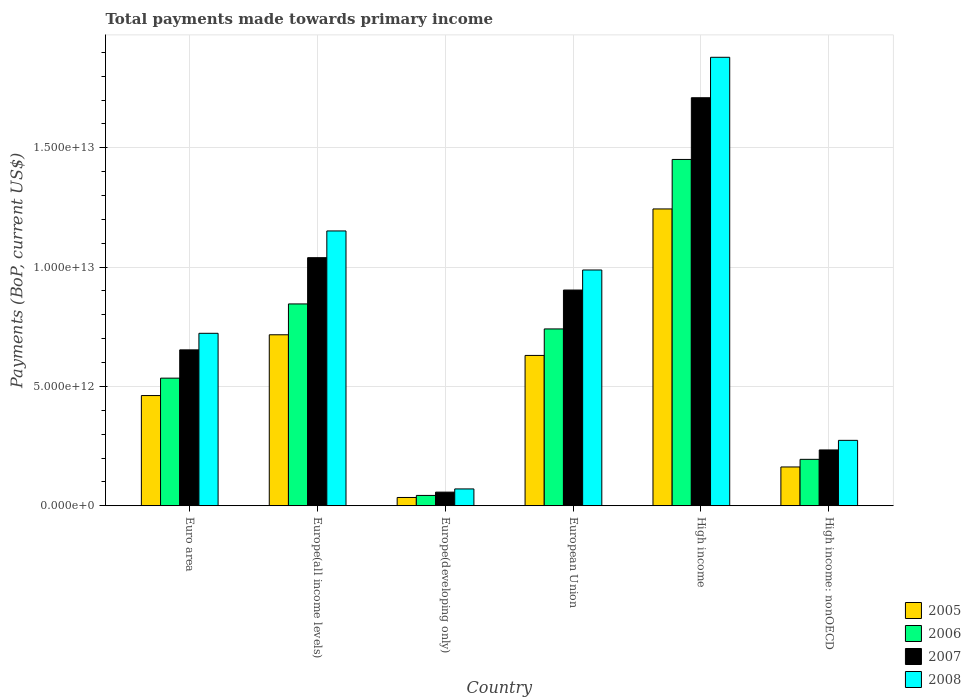How many groups of bars are there?
Give a very brief answer. 6. Are the number of bars per tick equal to the number of legend labels?
Ensure brevity in your answer.  Yes. Are the number of bars on each tick of the X-axis equal?
Offer a very short reply. Yes. How many bars are there on the 5th tick from the left?
Give a very brief answer. 4. How many bars are there on the 4th tick from the right?
Offer a very short reply. 4. What is the label of the 2nd group of bars from the left?
Your response must be concise. Europe(all income levels). What is the total payments made towards primary income in 2005 in Europe(developing only)?
Ensure brevity in your answer.  3.46e+11. Across all countries, what is the maximum total payments made towards primary income in 2008?
Your response must be concise. 1.88e+13. Across all countries, what is the minimum total payments made towards primary income in 2007?
Ensure brevity in your answer.  5.70e+11. In which country was the total payments made towards primary income in 2005 maximum?
Offer a very short reply. High income. In which country was the total payments made towards primary income in 2006 minimum?
Your answer should be very brief. Europe(developing only). What is the total total payments made towards primary income in 2006 in the graph?
Provide a short and direct response. 3.81e+13. What is the difference between the total payments made towards primary income in 2008 in Europe(developing only) and that in High income?
Your response must be concise. -1.81e+13. What is the difference between the total payments made towards primary income in 2007 in European Union and the total payments made towards primary income in 2006 in High income?
Offer a very short reply. -5.47e+12. What is the average total payments made towards primary income in 2008 per country?
Give a very brief answer. 8.48e+12. What is the difference between the total payments made towards primary income of/in 2005 and total payments made towards primary income of/in 2006 in High income: nonOECD?
Make the answer very short. -3.20e+11. In how many countries, is the total payments made towards primary income in 2005 greater than 8000000000000 US$?
Provide a succinct answer. 1. What is the ratio of the total payments made towards primary income in 2008 in Europe(developing only) to that in European Union?
Give a very brief answer. 0.07. Is the total payments made towards primary income in 2006 in Europe(all income levels) less than that in High income: nonOECD?
Your answer should be compact. No. Is the difference between the total payments made towards primary income in 2005 in Euro area and Europe(developing only) greater than the difference between the total payments made towards primary income in 2006 in Euro area and Europe(developing only)?
Offer a terse response. No. What is the difference between the highest and the second highest total payments made towards primary income in 2006?
Offer a terse response. 1.05e+12. What is the difference between the highest and the lowest total payments made towards primary income in 2005?
Offer a terse response. 1.21e+13. In how many countries, is the total payments made towards primary income in 2007 greater than the average total payments made towards primary income in 2007 taken over all countries?
Provide a succinct answer. 3. What does the 1st bar from the right in High income: nonOECD represents?
Provide a succinct answer. 2008. Is it the case that in every country, the sum of the total payments made towards primary income in 2008 and total payments made towards primary income in 2005 is greater than the total payments made towards primary income in 2006?
Your answer should be compact. Yes. How many bars are there?
Keep it short and to the point. 24. Are all the bars in the graph horizontal?
Give a very brief answer. No. How many countries are there in the graph?
Your response must be concise. 6. What is the difference between two consecutive major ticks on the Y-axis?
Give a very brief answer. 5.00e+12. Are the values on the major ticks of Y-axis written in scientific E-notation?
Make the answer very short. Yes. Does the graph contain any zero values?
Your response must be concise. No. Where does the legend appear in the graph?
Your answer should be compact. Bottom right. What is the title of the graph?
Your response must be concise. Total payments made towards primary income. What is the label or title of the X-axis?
Keep it short and to the point. Country. What is the label or title of the Y-axis?
Keep it short and to the point. Payments (BoP, current US$). What is the Payments (BoP, current US$) of 2005 in Euro area?
Your answer should be very brief. 4.62e+12. What is the Payments (BoP, current US$) in 2006 in Euro area?
Offer a very short reply. 5.35e+12. What is the Payments (BoP, current US$) of 2007 in Euro area?
Provide a short and direct response. 6.53e+12. What is the Payments (BoP, current US$) in 2008 in Euro area?
Offer a very short reply. 7.23e+12. What is the Payments (BoP, current US$) of 2005 in Europe(all income levels)?
Offer a terse response. 7.16e+12. What is the Payments (BoP, current US$) of 2006 in Europe(all income levels)?
Offer a terse response. 8.46e+12. What is the Payments (BoP, current US$) of 2007 in Europe(all income levels)?
Offer a terse response. 1.04e+13. What is the Payments (BoP, current US$) in 2008 in Europe(all income levels)?
Provide a short and direct response. 1.15e+13. What is the Payments (BoP, current US$) in 2005 in Europe(developing only)?
Keep it short and to the point. 3.46e+11. What is the Payments (BoP, current US$) of 2006 in Europe(developing only)?
Offer a terse response. 4.32e+11. What is the Payments (BoP, current US$) of 2007 in Europe(developing only)?
Provide a short and direct response. 5.70e+11. What is the Payments (BoP, current US$) of 2008 in Europe(developing only)?
Offer a very short reply. 7.04e+11. What is the Payments (BoP, current US$) of 2005 in European Union?
Your response must be concise. 6.30e+12. What is the Payments (BoP, current US$) of 2006 in European Union?
Your response must be concise. 7.41e+12. What is the Payments (BoP, current US$) of 2007 in European Union?
Give a very brief answer. 9.04e+12. What is the Payments (BoP, current US$) of 2008 in European Union?
Provide a succinct answer. 9.88e+12. What is the Payments (BoP, current US$) of 2005 in High income?
Provide a short and direct response. 1.24e+13. What is the Payments (BoP, current US$) of 2006 in High income?
Your response must be concise. 1.45e+13. What is the Payments (BoP, current US$) in 2007 in High income?
Your answer should be compact. 1.71e+13. What is the Payments (BoP, current US$) of 2008 in High income?
Your response must be concise. 1.88e+13. What is the Payments (BoP, current US$) of 2005 in High income: nonOECD?
Make the answer very short. 1.62e+12. What is the Payments (BoP, current US$) in 2006 in High income: nonOECD?
Keep it short and to the point. 1.94e+12. What is the Payments (BoP, current US$) in 2007 in High income: nonOECD?
Offer a terse response. 2.34e+12. What is the Payments (BoP, current US$) in 2008 in High income: nonOECD?
Give a very brief answer. 2.74e+12. Across all countries, what is the maximum Payments (BoP, current US$) of 2005?
Provide a short and direct response. 1.24e+13. Across all countries, what is the maximum Payments (BoP, current US$) in 2006?
Make the answer very short. 1.45e+13. Across all countries, what is the maximum Payments (BoP, current US$) in 2007?
Offer a very short reply. 1.71e+13. Across all countries, what is the maximum Payments (BoP, current US$) in 2008?
Provide a succinct answer. 1.88e+13. Across all countries, what is the minimum Payments (BoP, current US$) in 2005?
Offer a terse response. 3.46e+11. Across all countries, what is the minimum Payments (BoP, current US$) of 2006?
Your answer should be compact. 4.32e+11. Across all countries, what is the minimum Payments (BoP, current US$) in 2007?
Make the answer very short. 5.70e+11. Across all countries, what is the minimum Payments (BoP, current US$) of 2008?
Your response must be concise. 7.04e+11. What is the total Payments (BoP, current US$) in 2005 in the graph?
Offer a very short reply. 3.25e+13. What is the total Payments (BoP, current US$) of 2006 in the graph?
Give a very brief answer. 3.81e+13. What is the total Payments (BoP, current US$) of 2007 in the graph?
Provide a succinct answer. 4.60e+13. What is the total Payments (BoP, current US$) in 2008 in the graph?
Your answer should be very brief. 5.09e+13. What is the difference between the Payments (BoP, current US$) of 2005 in Euro area and that in Europe(all income levels)?
Keep it short and to the point. -2.55e+12. What is the difference between the Payments (BoP, current US$) of 2006 in Euro area and that in Europe(all income levels)?
Offer a very short reply. -3.11e+12. What is the difference between the Payments (BoP, current US$) of 2007 in Euro area and that in Europe(all income levels)?
Your answer should be compact. -3.86e+12. What is the difference between the Payments (BoP, current US$) in 2008 in Euro area and that in Europe(all income levels)?
Provide a short and direct response. -4.29e+12. What is the difference between the Payments (BoP, current US$) of 2005 in Euro area and that in Europe(developing only)?
Give a very brief answer. 4.27e+12. What is the difference between the Payments (BoP, current US$) of 2006 in Euro area and that in Europe(developing only)?
Provide a succinct answer. 4.92e+12. What is the difference between the Payments (BoP, current US$) of 2007 in Euro area and that in Europe(developing only)?
Ensure brevity in your answer.  5.96e+12. What is the difference between the Payments (BoP, current US$) of 2008 in Euro area and that in Europe(developing only)?
Keep it short and to the point. 6.52e+12. What is the difference between the Payments (BoP, current US$) of 2005 in Euro area and that in European Union?
Provide a short and direct response. -1.68e+12. What is the difference between the Payments (BoP, current US$) in 2006 in Euro area and that in European Union?
Ensure brevity in your answer.  -2.06e+12. What is the difference between the Payments (BoP, current US$) in 2007 in Euro area and that in European Union?
Offer a very short reply. -2.51e+12. What is the difference between the Payments (BoP, current US$) of 2008 in Euro area and that in European Union?
Make the answer very short. -2.65e+12. What is the difference between the Payments (BoP, current US$) in 2005 in Euro area and that in High income?
Make the answer very short. -7.82e+12. What is the difference between the Payments (BoP, current US$) in 2006 in Euro area and that in High income?
Provide a succinct answer. -9.17e+12. What is the difference between the Payments (BoP, current US$) of 2007 in Euro area and that in High income?
Provide a succinct answer. -1.06e+13. What is the difference between the Payments (BoP, current US$) of 2008 in Euro area and that in High income?
Ensure brevity in your answer.  -1.16e+13. What is the difference between the Payments (BoP, current US$) of 2005 in Euro area and that in High income: nonOECD?
Ensure brevity in your answer.  2.99e+12. What is the difference between the Payments (BoP, current US$) of 2006 in Euro area and that in High income: nonOECD?
Provide a short and direct response. 3.40e+12. What is the difference between the Payments (BoP, current US$) in 2007 in Euro area and that in High income: nonOECD?
Offer a terse response. 4.19e+12. What is the difference between the Payments (BoP, current US$) in 2008 in Euro area and that in High income: nonOECD?
Ensure brevity in your answer.  4.49e+12. What is the difference between the Payments (BoP, current US$) of 2005 in Europe(all income levels) and that in Europe(developing only)?
Your answer should be very brief. 6.82e+12. What is the difference between the Payments (BoP, current US$) of 2006 in Europe(all income levels) and that in Europe(developing only)?
Keep it short and to the point. 8.03e+12. What is the difference between the Payments (BoP, current US$) of 2007 in Europe(all income levels) and that in Europe(developing only)?
Your response must be concise. 9.83e+12. What is the difference between the Payments (BoP, current US$) of 2008 in Europe(all income levels) and that in Europe(developing only)?
Make the answer very short. 1.08e+13. What is the difference between the Payments (BoP, current US$) of 2005 in Europe(all income levels) and that in European Union?
Keep it short and to the point. 8.66e+11. What is the difference between the Payments (BoP, current US$) in 2006 in Europe(all income levels) and that in European Union?
Ensure brevity in your answer.  1.05e+12. What is the difference between the Payments (BoP, current US$) of 2007 in Europe(all income levels) and that in European Union?
Your answer should be very brief. 1.36e+12. What is the difference between the Payments (BoP, current US$) of 2008 in Europe(all income levels) and that in European Union?
Your answer should be very brief. 1.64e+12. What is the difference between the Payments (BoP, current US$) in 2005 in Europe(all income levels) and that in High income?
Offer a terse response. -5.27e+12. What is the difference between the Payments (BoP, current US$) in 2006 in Europe(all income levels) and that in High income?
Ensure brevity in your answer.  -6.06e+12. What is the difference between the Payments (BoP, current US$) in 2007 in Europe(all income levels) and that in High income?
Make the answer very short. -6.70e+12. What is the difference between the Payments (BoP, current US$) of 2008 in Europe(all income levels) and that in High income?
Provide a short and direct response. -7.28e+12. What is the difference between the Payments (BoP, current US$) in 2005 in Europe(all income levels) and that in High income: nonOECD?
Your response must be concise. 5.54e+12. What is the difference between the Payments (BoP, current US$) in 2006 in Europe(all income levels) and that in High income: nonOECD?
Your answer should be compact. 6.51e+12. What is the difference between the Payments (BoP, current US$) in 2007 in Europe(all income levels) and that in High income: nonOECD?
Give a very brief answer. 8.06e+12. What is the difference between the Payments (BoP, current US$) of 2008 in Europe(all income levels) and that in High income: nonOECD?
Your answer should be compact. 8.78e+12. What is the difference between the Payments (BoP, current US$) of 2005 in Europe(developing only) and that in European Union?
Offer a very short reply. -5.95e+12. What is the difference between the Payments (BoP, current US$) of 2006 in Europe(developing only) and that in European Union?
Offer a terse response. -6.98e+12. What is the difference between the Payments (BoP, current US$) in 2007 in Europe(developing only) and that in European Union?
Provide a short and direct response. -8.47e+12. What is the difference between the Payments (BoP, current US$) in 2008 in Europe(developing only) and that in European Union?
Ensure brevity in your answer.  -9.18e+12. What is the difference between the Payments (BoP, current US$) of 2005 in Europe(developing only) and that in High income?
Make the answer very short. -1.21e+13. What is the difference between the Payments (BoP, current US$) in 2006 in Europe(developing only) and that in High income?
Your answer should be very brief. -1.41e+13. What is the difference between the Payments (BoP, current US$) in 2007 in Europe(developing only) and that in High income?
Provide a succinct answer. -1.65e+13. What is the difference between the Payments (BoP, current US$) in 2008 in Europe(developing only) and that in High income?
Provide a succinct answer. -1.81e+13. What is the difference between the Payments (BoP, current US$) of 2005 in Europe(developing only) and that in High income: nonOECD?
Make the answer very short. -1.28e+12. What is the difference between the Payments (BoP, current US$) in 2006 in Europe(developing only) and that in High income: nonOECD?
Provide a succinct answer. -1.51e+12. What is the difference between the Payments (BoP, current US$) of 2007 in Europe(developing only) and that in High income: nonOECD?
Give a very brief answer. -1.77e+12. What is the difference between the Payments (BoP, current US$) in 2008 in Europe(developing only) and that in High income: nonOECD?
Make the answer very short. -2.04e+12. What is the difference between the Payments (BoP, current US$) of 2005 in European Union and that in High income?
Provide a short and direct response. -6.14e+12. What is the difference between the Payments (BoP, current US$) of 2006 in European Union and that in High income?
Your answer should be compact. -7.10e+12. What is the difference between the Payments (BoP, current US$) in 2007 in European Union and that in High income?
Offer a terse response. -8.06e+12. What is the difference between the Payments (BoP, current US$) of 2008 in European Union and that in High income?
Your response must be concise. -8.91e+12. What is the difference between the Payments (BoP, current US$) in 2005 in European Union and that in High income: nonOECD?
Provide a short and direct response. 4.67e+12. What is the difference between the Payments (BoP, current US$) of 2006 in European Union and that in High income: nonOECD?
Ensure brevity in your answer.  5.47e+12. What is the difference between the Payments (BoP, current US$) in 2007 in European Union and that in High income: nonOECD?
Ensure brevity in your answer.  6.70e+12. What is the difference between the Payments (BoP, current US$) in 2008 in European Union and that in High income: nonOECD?
Give a very brief answer. 7.14e+12. What is the difference between the Payments (BoP, current US$) in 2005 in High income and that in High income: nonOECD?
Your answer should be compact. 1.08e+13. What is the difference between the Payments (BoP, current US$) of 2006 in High income and that in High income: nonOECD?
Your response must be concise. 1.26e+13. What is the difference between the Payments (BoP, current US$) of 2007 in High income and that in High income: nonOECD?
Offer a very short reply. 1.48e+13. What is the difference between the Payments (BoP, current US$) of 2008 in High income and that in High income: nonOECD?
Your answer should be compact. 1.61e+13. What is the difference between the Payments (BoP, current US$) of 2005 in Euro area and the Payments (BoP, current US$) of 2006 in Europe(all income levels)?
Offer a very short reply. -3.84e+12. What is the difference between the Payments (BoP, current US$) in 2005 in Euro area and the Payments (BoP, current US$) in 2007 in Europe(all income levels)?
Give a very brief answer. -5.78e+12. What is the difference between the Payments (BoP, current US$) in 2005 in Euro area and the Payments (BoP, current US$) in 2008 in Europe(all income levels)?
Your response must be concise. -6.90e+12. What is the difference between the Payments (BoP, current US$) of 2006 in Euro area and the Payments (BoP, current US$) of 2007 in Europe(all income levels)?
Your response must be concise. -5.05e+12. What is the difference between the Payments (BoP, current US$) of 2006 in Euro area and the Payments (BoP, current US$) of 2008 in Europe(all income levels)?
Offer a terse response. -6.17e+12. What is the difference between the Payments (BoP, current US$) in 2007 in Euro area and the Payments (BoP, current US$) in 2008 in Europe(all income levels)?
Your answer should be compact. -4.98e+12. What is the difference between the Payments (BoP, current US$) in 2005 in Euro area and the Payments (BoP, current US$) in 2006 in Europe(developing only)?
Your answer should be very brief. 4.19e+12. What is the difference between the Payments (BoP, current US$) of 2005 in Euro area and the Payments (BoP, current US$) of 2007 in Europe(developing only)?
Give a very brief answer. 4.05e+12. What is the difference between the Payments (BoP, current US$) of 2005 in Euro area and the Payments (BoP, current US$) of 2008 in Europe(developing only)?
Provide a succinct answer. 3.91e+12. What is the difference between the Payments (BoP, current US$) of 2006 in Euro area and the Payments (BoP, current US$) of 2007 in Europe(developing only)?
Offer a very short reply. 4.78e+12. What is the difference between the Payments (BoP, current US$) in 2006 in Euro area and the Payments (BoP, current US$) in 2008 in Europe(developing only)?
Your answer should be compact. 4.64e+12. What is the difference between the Payments (BoP, current US$) in 2007 in Euro area and the Payments (BoP, current US$) in 2008 in Europe(developing only)?
Provide a succinct answer. 5.83e+12. What is the difference between the Payments (BoP, current US$) in 2005 in Euro area and the Payments (BoP, current US$) in 2006 in European Union?
Give a very brief answer. -2.79e+12. What is the difference between the Payments (BoP, current US$) in 2005 in Euro area and the Payments (BoP, current US$) in 2007 in European Union?
Offer a very short reply. -4.42e+12. What is the difference between the Payments (BoP, current US$) of 2005 in Euro area and the Payments (BoP, current US$) of 2008 in European Union?
Provide a succinct answer. -5.26e+12. What is the difference between the Payments (BoP, current US$) of 2006 in Euro area and the Payments (BoP, current US$) of 2007 in European Union?
Ensure brevity in your answer.  -3.69e+12. What is the difference between the Payments (BoP, current US$) of 2006 in Euro area and the Payments (BoP, current US$) of 2008 in European Union?
Make the answer very short. -4.53e+12. What is the difference between the Payments (BoP, current US$) in 2007 in Euro area and the Payments (BoP, current US$) in 2008 in European Union?
Give a very brief answer. -3.35e+12. What is the difference between the Payments (BoP, current US$) of 2005 in Euro area and the Payments (BoP, current US$) of 2006 in High income?
Your answer should be compact. -9.90e+12. What is the difference between the Payments (BoP, current US$) of 2005 in Euro area and the Payments (BoP, current US$) of 2007 in High income?
Give a very brief answer. -1.25e+13. What is the difference between the Payments (BoP, current US$) of 2005 in Euro area and the Payments (BoP, current US$) of 2008 in High income?
Keep it short and to the point. -1.42e+13. What is the difference between the Payments (BoP, current US$) of 2006 in Euro area and the Payments (BoP, current US$) of 2007 in High income?
Keep it short and to the point. -1.18e+13. What is the difference between the Payments (BoP, current US$) of 2006 in Euro area and the Payments (BoP, current US$) of 2008 in High income?
Offer a terse response. -1.34e+13. What is the difference between the Payments (BoP, current US$) of 2007 in Euro area and the Payments (BoP, current US$) of 2008 in High income?
Offer a very short reply. -1.23e+13. What is the difference between the Payments (BoP, current US$) of 2005 in Euro area and the Payments (BoP, current US$) of 2006 in High income: nonOECD?
Keep it short and to the point. 2.67e+12. What is the difference between the Payments (BoP, current US$) of 2005 in Euro area and the Payments (BoP, current US$) of 2007 in High income: nonOECD?
Your response must be concise. 2.28e+12. What is the difference between the Payments (BoP, current US$) of 2005 in Euro area and the Payments (BoP, current US$) of 2008 in High income: nonOECD?
Provide a short and direct response. 1.88e+12. What is the difference between the Payments (BoP, current US$) of 2006 in Euro area and the Payments (BoP, current US$) of 2007 in High income: nonOECD?
Your response must be concise. 3.01e+12. What is the difference between the Payments (BoP, current US$) in 2006 in Euro area and the Payments (BoP, current US$) in 2008 in High income: nonOECD?
Ensure brevity in your answer.  2.61e+12. What is the difference between the Payments (BoP, current US$) in 2007 in Euro area and the Payments (BoP, current US$) in 2008 in High income: nonOECD?
Keep it short and to the point. 3.79e+12. What is the difference between the Payments (BoP, current US$) of 2005 in Europe(all income levels) and the Payments (BoP, current US$) of 2006 in Europe(developing only)?
Offer a terse response. 6.73e+12. What is the difference between the Payments (BoP, current US$) in 2005 in Europe(all income levels) and the Payments (BoP, current US$) in 2007 in Europe(developing only)?
Make the answer very short. 6.60e+12. What is the difference between the Payments (BoP, current US$) of 2005 in Europe(all income levels) and the Payments (BoP, current US$) of 2008 in Europe(developing only)?
Your response must be concise. 6.46e+12. What is the difference between the Payments (BoP, current US$) in 2006 in Europe(all income levels) and the Payments (BoP, current US$) in 2007 in Europe(developing only)?
Provide a succinct answer. 7.89e+12. What is the difference between the Payments (BoP, current US$) in 2006 in Europe(all income levels) and the Payments (BoP, current US$) in 2008 in Europe(developing only)?
Ensure brevity in your answer.  7.75e+12. What is the difference between the Payments (BoP, current US$) in 2007 in Europe(all income levels) and the Payments (BoP, current US$) in 2008 in Europe(developing only)?
Offer a terse response. 9.69e+12. What is the difference between the Payments (BoP, current US$) of 2005 in Europe(all income levels) and the Payments (BoP, current US$) of 2006 in European Union?
Provide a short and direct response. -2.45e+11. What is the difference between the Payments (BoP, current US$) in 2005 in Europe(all income levels) and the Payments (BoP, current US$) in 2007 in European Union?
Give a very brief answer. -1.87e+12. What is the difference between the Payments (BoP, current US$) of 2005 in Europe(all income levels) and the Payments (BoP, current US$) of 2008 in European Union?
Provide a short and direct response. -2.71e+12. What is the difference between the Payments (BoP, current US$) of 2006 in Europe(all income levels) and the Payments (BoP, current US$) of 2007 in European Union?
Your response must be concise. -5.82e+11. What is the difference between the Payments (BoP, current US$) of 2006 in Europe(all income levels) and the Payments (BoP, current US$) of 2008 in European Union?
Give a very brief answer. -1.42e+12. What is the difference between the Payments (BoP, current US$) in 2007 in Europe(all income levels) and the Payments (BoP, current US$) in 2008 in European Union?
Offer a terse response. 5.16e+11. What is the difference between the Payments (BoP, current US$) of 2005 in Europe(all income levels) and the Payments (BoP, current US$) of 2006 in High income?
Keep it short and to the point. -7.35e+12. What is the difference between the Payments (BoP, current US$) of 2005 in Europe(all income levels) and the Payments (BoP, current US$) of 2007 in High income?
Offer a very short reply. -9.93e+12. What is the difference between the Payments (BoP, current US$) in 2005 in Europe(all income levels) and the Payments (BoP, current US$) in 2008 in High income?
Offer a terse response. -1.16e+13. What is the difference between the Payments (BoP, current US$) in 2006 in Europe(all income levels) and the Payments (BoP, current US$) in 2007 in High income?
Your response must be concise. -8.64e+12. What is the difference between the Payments (BoP, current US$) in 2006 in Europe(all income levels) and the Payments (BoP, current US$) in 2008 in High income?
Your answer should be compact. -1.03e+13. What is the difference between the Payments (BoP, current US$) of 2007 in Europe(all income levels) and the Payments (BoP, current US$) of 2008 in High income?
Provide a short and direct response. -8.40e+12. What is the difference between the Payments (BoP, current US$) in 2005 in Europe(all income levels) and the Payments (BoP, current US$) in 2006 in High income: nonOECD?
Offer a terse response. 5.22e+12. What is the difference between the Payments (BoP, current US$) in 2005 in Europe(all income levels) and the Payments (BoP, current US$) in 2007 in High income: nonOECD?
Your answer should be compact. 4.83e+12. What is the difference between the Payments (BoP, current US$) of 2005 in Europe(all income levels) and the Payments (BoP, current US$) of 2008 in High income: nonOECD?
Provide a succinct answer. 4.42e+12. What is the difference between the Payments (BoP, current US$) of 2006 in Europe(all income levels) and the Payments (BoP, current US$) of 2007 in High income: nonOECD?
Provide a short and direct response. 6.12e+12. What is the difference between the Payments (BoP, current US$) of 2006 in Europe(all income levels) and the Payments (BoP, current US$) of 2008 in High income: nonOECD?
Provide a short and direct response. 5.72e+12. What is the difference between the Payments (BoP, current US$) of 2007 in Europe(all income levels) and the Payments (BoP, current US$) of 2008 in High income: nonOECD?
Make the answer very short. 7.66e+12. What is the difference between the Payments (BoP, current US$) of 2005 in Europe(developing only) and the Payments (BoP, current US$) of 2006 in European Union?
Provide a short and direct response. -7.06e+12. What is the difference between the Payments (BoP, current US$) in 2005 in Europe(developing only) and the Payments (BoP, current US$) in 2007 in European Union?
Offer a terse response. -8.69e+12. What is the difference between the Payments (BoP, current US$) of 2005 in Europe(developing only) and the Payments (BoP, current US$) of 2008 in European Union?
Your response must be concise. -9.53e+12. What is the difference between the Payments (BoP, current US$) of 2006 in Europe(developing only) and the Payments (BoP, current US$) of 2007 in European Union?
Give a very brief answer. -8.61e+12. What is the difference between the Payments (BoP, current US$) in 2006 in Europe(developing only) and the Payments (BoP, current US$) in 2008 in European Union?
Offer a very short reply. -9.45e+12. What is the difference between the Payments (BoP, current US$) in 2007 in Europe(developing only) and the Payments (BoP, current US$) in 2008 in European Union?
Give a very brief answer. -9.31e+12. What is the difference between the Payments (BoP, current US$) of 2005 in Europe(developing only) and the Payments (BoP, current US$) of 2006 in High income?
Offer a terse response. -1.42e+13. What is the difference between the Payments (BoP, current US$) in 2005 in Europe(developing only) and the Payments (BoP, current US$) in 2007 in High income?
Provide a short and direct response. -1.68e+13. What is the difference between the Payments (BoP, current US$) in 2005 in Europe(developing only) and the Payments (BoP, current US$) in 2008 in High income?
Your answer should be very brief. -1.84e+13. What is the difference between the Payments (BoP, current US$) in 2006 in Europe(developing only) and the Payments (BoP, current US$) in 2007 in High income?
Your response must be concise. -1.67e+13. What is the difference between the Payments (BoP, current US$) in 2006 in Europe(developing only) and the Payments (BoP, current US$) in 2008 in High income?
Your answer should be very brief. -1.84e+13. What is the difference between the Payments (BoP, current US$) of 2007 in Europe(developing only) and the Payments (BoP, current US$) of 2008 in High income?
Provide a succinct answer. -1.82e+13. What is the difference between the Payments (BoP, current US$) of 2005 in Europe(developing only) and the Payments (BoP, current US$) of 2006 in High income: nonOECD?
Keep it short and to the point. -1.60e+12. What is the difference between the Payments (BoP, current US$) in 2005 in Europe(developing only) and the Payments (BoP, current US$) in 2007 in High income: nonOECD?
Provide a succinct answer. -1.99e+12. What is the difference between the Payments (BoP, current US$) of 2005 in Europe(developing only) and the Payments (BoP, current US$) of 2008 in High income: nonOECD?
Offer a very short reply. -2.39e+12. What is the difference between the Payments (BoP, current US$) in 2006 in Europe(developing only) and the Payments (BoP, current US$) in 2007 in High income: nonOECD?
Your answer should be very brief. -1.91e+12. What is the difference between the Payments (BoP, current US$) in 2006 in Europe(developing only) and the Payments (BoP, current US$) in 2008 in High income: nonOECD?
Your answer should be very brief. -2.31e+12. What is the difference between the Payments (BoP, current US$) in 2007 in Europe(developing only) and the Payments (BoP, current US$) in 2008 in High income: nonOECD?
Offer a very short reply. -2.17e+12. What is the difference between the Payments (BoP, current US$) of 2005 in European Union and the Payments (BoP, current US$) of 2006 in High income?
Offer a terse response. -8.21e+12. What is the difference between the Payments (BoP, current US$) in 2005 in European Union and the Payments (BoP, current US$) in 2007 in High income?
Your answer should be very brief. -1.08e+13. What is the difference between the Payments (BoP, current US$) in 2005 in European Union and the Payments (BoP, current US$) in 2008 in High income?
Make the answer very short. -1.25e+13. What is the difference between the Payments (BoP, current US$) in 2006 in European Union and the Payments (BoP, current US$) in 2007 in High income?
Your response must be concise. -9.69e+12. What is the difference between the Payments (BoP, current US$) in 2006 in European Union and the Payments (BoP, current US$) in 2008 in High income?
Offer a very short reply. -1.14e+13. What is the difference between the Payments (BoP, current US$) of 2007 in European Union and the Payments (BoP, current US$) of 2008 in High income?
Your answer should be compact. -9.75e+12. What is the difference between the Payments (BoP, current US$) of 2005 in European Union and the Payments (BoP, current US$) of 2006 in High income: nonOECD?
Keep it short and to the point. 4.35e+12. What is the difference between the Payments (BoP, current US$) of 2005 in European Union and the Payments (BoP, current US$) of 2007 in High income: nonOECD?
Your response must be concise. 3.96e+12. What is the difference between the Payments (BoP, current US$) of 2005 in European Union and the Payments (BoP, current US$) of 2008 in High income: nonOECD?
Offer a very short reply. 3.56e+12. What is the difference between the Payments (BoP, current US$) of 2006 in European Union and the Payments (BoP, current US$) of 2007 in High income: nonOECD?
Give a very brief answer. 5.07e+12. What is the difference between the Payments (BoP, current US$) in 2006 in European Union and the Payments (BoP, current US$) in 2008 in High income: nonOECD?
Provide a short and direct response. 4.67e+12. What is the difference between the Payments (BoP, current US$) in 2007 in European Union and the Payments (BoP, current US$) in 2008 in High income: nonOECD?
Offer a very short reply. 6.30e+12. What is the difference between the Payments (BoP, current US$) of 2005 in High income and the Payments (BoP, current US$) of 2006 in High income: nonOECD?
Offer a very short reply. 1.05e+13. What is the difference between the Payments (BoP, current US$) in 2005 in High income and the Payments (BoP, current US$) in 2007 in High income: nonOECD?
Offer a terse response. 1.01e+13. What is the difference between the Payments (BoP, current US$) in 2005 in High income and the Payments (BoP, current US$) in 2008 in High income: nonOECD?
Your response must be concise. 9.70e+12. What is the difference between the Payments (BoP, current US$) of 2006 in High income and the Payments (BoP, current US$) of 2007 in High income: nonOECD?
Your answer should be compact. 1.22e+13. What is the difference between the Payments (BoP, current US$) in 2006 in High income and the Payments (BoP, current US$) in 2008 in High income: nonOECD?
Your response must be concise. 1.18e+13. What is the difference between the Payments (BoP, current US$) of 2007 in High income and the Payments (BoP, current US$) of 2008 in High income: nonOECD?
Provide a short and direct response. 1.44e+13. What is the average Payments (BoP, current US$) in 2005 per country?
Make the answer very short. 5.42e+12. What is the average Payments (BoP, current US$) of 2006 per country?
Give a very brief answer. 6.35e+12. What is the average Payments (BoP, current US$) in 2007 per country?
Your answer should be very brief. 7.66e+12. What is the average Payments (BoP, current US$) in 2008 per country?
Your response must be concise. 8.48e+12. What is the difference between the Payments (BoP, current US$) in 2005 and Payments (BoP, current US$) in 2006 in Euro area?
Offer a terse response. -7.29e+11. What is the difference between the Payments (BoP, current US$) of 2005 and Payments (BoP, current US$) of 2007 in Euro area?
Offer a very short reply. -1.91e+12. What is the difference between the Payments (BoP, current US$) of 2005 and Payments (BoP, current US$) of 2008 in Euro area?
Offer a very short reply. -2.61e+12. What is the difference between the Payments (BoP, current US$) in 2006 and Payments (BoP, current US$) in 2007 in Euro area?
Offer a terse response. -1.19e+12. What is the difference between the Payments (BoP, current US$) in 2006 and Payments (BoP, current US$) in 2008 in Euro area?
Offer a terse response. -1.88e+12. What is the difference between the Payments (BoP, current US$) of 2007 and Payments (BoP, current US$) of 2008 in Euro area?
Provide a succinct answer. -6.94e+11. What is the difference between the Payments (BoP, current US$) of 2005 and Payments (BoP, current US$) of 2006 in Europe(all income levels)?
Your answer should be very brief. -1.29e+12. What is the difference between the Payments (BoP, current US$) of 2005 and Payments (BoP, current US$) of 2007 in Europe(all income levels)?
Ensure brevity in your answer.  -3.23e+12. What is the difference between the Payments (BoP, current US$) in 2005 and Payments (BoP, current US$) in 2008 in Europe(all income levels)?
Your answer should be compact. -4.35e+12. What is the difference between the Payments (BoP, current US$) in 2006 and Payments (BoP, current US$) in 2007 in Europe(all income levels)?
Ensure brevity in your answer.  -1.94e+12. What is the difference between the Payments (BoP, current US$) in 2006 and Payments (BoP, current US$) in 2008 in Europe(all income levels)?
Provide a short and direct response. -3.06e+12. What is the difference between the Payments (BoP, current US$) in 2007 and Payments (BoP, current US$) in 2008 in Europe(all income levels)?
Provide a short and direct response. -1.12e+12. What is the difference between the Payments (BoP, current US$) in 2005 and Payments (BoP, current US$) in 2006 in Europe(developing only)?
Offer a terse response. -8.59e+1. What is the difference between the Payments (BoP, current US$) of 2005 and Payments (BoP, current US$) of 2007 in Europe(developing only)?
Ensure brevity in your answer.  -2.24e+11. What is the difference between the Payments (BoP, current US$) of 2005 and Payments (BoP, current US$) of 2008 in Europe(developing only)?
Your answer should be compact. -3.58e+11. What is the difference between the Payments (BoP, current US$) of 2006 and Payments (BoP, current US$) of 2007 in Europe(developing only)?
Give a very brief answer. -1.38e+11. What is the difference between the Payments (BoP, current US$) in 2006 and Payments (BoP, current US$) in 2008 in Europe(developing only)?
Your answer should be very brief. -2.72e+11. What is the difference between the Payments (BoP, current US$) in 2007 and Payments (BoP, current US$) in 2008 in Europe(developing only)?
Give a very brief answer. -1.34e+11. What is the difference between the Payments (BoP, current US$) of 2005 and Payments (BoP, current US$) of 2006 in European Union?
Offer a very short reply. -1.11e+12. What is the difference between the Payments (BoP, current US$) of 2005 and Payments (BoP, current US$) of 2007 in European Union?
Your response must be concise. -2.74e+12. What is the difference between the Payments (BoP, current US$) of 2005 and Payments (BoP, current US$) of 2008 in European Union?
Offer a very short reply. -3.58e+12. What is the difference between the Payments (BoP, current US$) of 2006 and Payments (BoP, current US$) of 2007 in European Union?
Give a very brief answer. -1.63e+12. What is the difference between the Payments (BoP, current US$) in 2006 and Payments (BoP, current US$) in 2008 in European Union?
Your answer should be very brief. -2.47e+12. What is the difference between the Payments (BoP, current US$) of 2007 and Payments (BoP, current US$) of 2008 in European Union?
Your answer should be compact. -8.40e+11. What is the difference between the Payments (BoP, current US$) of 2005 and Payments (BoP, current US$) of 2006 in High income?
Provide a short and direct response. -2.07e+12. What is the difference between the Payments (BoP, current US$) in 2005 and Payments (BoP, current US$) in 2007 in High income?
Offer a very short reply. -4.66e+12. What is the difference between the Payments (BoP, current US$) in 2005 and Payments (BoP, current US$) in 2008 in High income?
Your answer should be very brief. -6.36e+12. What is the difference between the Payments (BoP, current US$) in 2006 and Payments (BoP, current US$) in 2007 in High income?
Keep it short and to the point. -2.59e+12. What is the difference between the Payments (BoP, current US$) of 2006 and Payments (BoP, current US$) of 2008 in High income?
Your answer should be very brief. -4.28e+12. What is the difference between the Payments (BoP, current US$) in 2007 and Payments (BoP, current US$) in 2008 in High income?
Keep it short and to the point. -1.69e+12. What is the difference between the Payments (BoP, current US$) of 2005 and Payments (BoP, current US$) of 2006 in High income: nonOECD?
Offer a very short reply. -3.20e+11. What is the difference between the Payments (BoP, current US$) of 2005 and Payments (BoP, current US$) of 2007 in High income: nonOECD?
Provide a succinct answer. -7.13e+11. What is the difference between the Payments (BoP, current US$) of 2005 and Payments (BoP, current US$) of 2008 in High income: nonOECD?
Make the answer very short. -1.12e+12. What is the difference between the Payments (BoP, current US$) in 2006 and Payments (BoP, current US$) in 2007 in High income: nonOECD?
Your answer should be very brief. -3.94e+11. What is the difference between the Payments (BoP, current US$) of 2006 and Payments (BoP, current US$) of 2008 in High income: nonOECD?
Ensure brevity in your answer.  -7.96e+11. What is the difference between the Payments (BoP, current US$) of 2007 and Payments (BoP, current US$) of 2008 in High income: nonOECD?
Your response must be concise. -4.02e+11. What is the ratio of the Payments (BoP, current US$) in 2005 in Euro area to that in Europe(all income levels)?
Offer a terse response. 0.64. What is the ratio of the Payments (BoP, current US$) of 2006 in Euro area to that in Europe(all income levels)?
Give a very brief answer. 0.63. What is the ratio of the Payments (BoP, current US$) of 2007 in Euro area to that in Europe(all income levels)?
Your answer should be very brief. 0.63. What is the ratio of the Payments (BoP, current US$) in 2008 in Euro area to that in Europe(all income levels)?
Make the answer very short. 0.63. What is the ratio of the Payments (BoP, current US$) of 2005 in Euro area to that in Europe(developing only)?
Offer a very short reply. 13.36. What is the ratio of the Payments (BoP, current US$) in 2006 in Euro area to that in Europe(developing only)?
Give a very brief answer. 12.39. What is the ratio of the Payments (BoP, current US$) in 2007 in Euro area to that in Europe(developing only)?
Keep it short and to the point. 11.47. What is the ratio of the Payments (BoP, current US$) in 2008 in Euro area to that in Europe(developing only)?
Your answer should be compact. 10.27. What is the ratio of the Payments (BoP, current US$) in 2005 in Euro area to that in European Union?
Your answer should be very brief. 0.73. What is the ratio of the Payments (BoP, current US$) of 2006 in Euro area to that in European Union?
Make the answer very short. 0.72. What is the ratio of the Payments (BoP, current US$) of 2007 in Euro area to that in European Union?
Ensure brevity in your answer.  0.72. What is the ratio of the Payments (BoP, current US$) of 2008 in Euro area to that in European Union?
Keep it short and to the point. 0.73. What is the ratio of the Payments (BoP, current US$) in 2005 in Euro area to that in High income?
Keep it short and to the point. 0.37. What is the ratio of the Payments (BoP, current US$) of 2006 in Euro area to that in High income?
Provide a succinct answer. 0.37. What is the ratio of the Payments (BoP, current US$) of 2007 in Euro area to that in High income?
Offer a very short reply. 0.38. What is the ratio of the Payments (BoP, current US$) in 2008 in Euro area to that in High income?
Your response must be concise. 0.38. What is the ratio of the Payments (BoP, current US$) of 2005 in Euro area to that in High income: nonOECD?
Make the answer very short. 2.84. What is the ratio of the Payments (BoP, current US$) in 2006 in Euro area to that in High income: nonOECD?
Your answer should be compact. 2.75. What is the ratio of the Payments (BoP, current US$) in 2007 in Euro area to that in High income: nonOECD?
Provide a short and direct response. 2.79. What is the ratio of the Payments (BoP, current US$) of 2008 in Euro area to that in High income: nonOECD?
Your answer should be very brief. 2.64. What is the ratio of the Payments (BoP, current US$) in 2005 in Europe(all income levels) to that in Europe(developing only)?
Give a very brief answer. 20.73. What is the ratio of the Payments (BoP, current US$) of 2006 in Europe(all income levels) to that in Europe(developing only)?
Offer a terse response. 19.59. What is the ratio of the Payments (BoP, current US$) of 2007 in Europe(all income levels) to that in Europe(developing only)?
Provide a short and direct response. 18.25. What is the ratio of the Payments (BoP, current US$) in 2008 in Europe(all income levels) to that in Europe(developing only)?
Your response must be concise. 16.36. What is the ratio of the Payments (BoP, current US$) of 2005 in Europe(all income levels) to that in European Union?
Keep it short and to the point. 1.14. What is the ratio of the Payments (BoP, current US$) in 2006 in Europe(all income levels) to that in European Union?
Offer a very short reply. 1.14. What is the ratio of the Payments (BoP, current US$) of 2007 in Europe(all income levels) to that in European Union?
Give a very brief answer. 1.15. What is the ratio of the Payments (BoP, current US$) of 2008 in Europe(all income levels) to that in European Union?
Your answer should be very brief. 1.17. What is the ratio of the Payments (BoP, current US$) of 2005 in Europe(all income levels) to that in High income?
Give a very brief answer. 0.58. What is the ratio of the Payments (BoP, current US$) of 2006 in Europe(all income levels) to that in High income?
Provide a succinct answer. 0.58. What is the ratio of the Payments (BoP, current US$) of 2007 in Europe(all income levels) to that in High income?
Provide a short and direct response. 0.61. What is the ratio of the Payments (BoP, current US$) in 2008 in Europe(all income levels) to that in High income?
Offer a terse response. 0.61. What is the ratio of the Payments (BoP, current US$) in 2005 in Europe(all income levels) to that in High income: nonOECD?
Your response must be concise. 4.41. What is the ratio of the Payments (BoP, current US$) of 2006 in Europe(all income levels) to that in High income: nonOECD?
Make the answer very short. 4.35. What is the ratio of the Payments (BoP, current US$) of 2007 in Europe(all income levels) to that in High income: nonOECD?
Provide a succinct answer. 4.45. What is the ratio of the Payments (BoP, current US$) of 2008 in Europe(all income levels) to that in High income: nonOECD?
Provide a short and direct response. 4.2. What is the ratio of the Payments (BoP, current US$) of 2005 in Europe(developing only) to that in European Union?
Keep it short and to the point. 0.05. What is the ratio of the Payments (BoP, current US$) of 2006 in Europe(developing only) to that in European Union?
Your answer should be compact. 0.06. What is the ratio of the Payments (BoP, current US$) in 2007 in Europe(developing only) to that in European Union?
Give a very brief answer. 0.06. What is the ratio of the Payments (BoP, current US$) in 2008 in Europe(developing only) to that in European Union?
Offer a very short reply. 0.07. What is the ratio of the Payments (BoP, current US$) in 2005 in Europe(developing only) to that in High income?
Your response must be concise. 0.03. What is the ratio of the Payments (BoP, current US$) of 2006 in Europe(developing only) to that in High income?
Your answer should be very brief. 0.03. What is the ratio of the Payments (BoP, current US$) of 2007 in Europe(developing only) to that in High income?
Your response must be concise. 0.03. What is the ratio of the Payments (BoP, current US$) of 2008 in Europe(developing only) to that in High income?
Ensure brevity in your answer.  0.04. What is the ratio of the Payments (BoP, current US$) of 2005 in Europe(developing only) to that in High income: nonOECD?
Offer a terse response. 0.21. What is the ratio of the Payments (BoP, current US$) of 2006 in Europe(developing only) to that in High income: nonOECD?
Your response must be concise. 0.22. What is the ratio of the Payments (BoP, current US$) of 2007 in Europe(developing only) to that in High income: nonOECD?
Keep it short and to the point. 0.24. What is the ratio of the Payments (BoP, current US$) in 2008 in Europe(developing only) to that in High income: nonOECD?
Offer a terse response. 0.26. What is the ratio of the Payments (BoP, current US$) of 2005 in European Union to that in High income?
Keep it short and to the point. 0.51. What is the ratio of the Payments (BoP, current US$) in 2006 in European Union to that in High income?
Provide a short and direct response. 0.51. What is the ratio of the Payments (BoP, current US$) in 2007 in European Union to that in High income?
Keep it short and to the point. 0.53. What is the ratio of the Payments (BoP, current US$) of 2008 in European Union to that in High income?
Keep it short and to the point. 0.53. What is the ratio of the Payments (BoP, current US$) in 2005 in European Union to that in High income: nonOECD?
Make the answer very short. 3.88. What is the ratio of the Payments (BoP, current US$) of 2006 in European Union to that in High income: nonOECD?
Make the answer very short. 3.81. What is the ratio of the Payments (BoP, current US$) in 2007 in European Union to that in High income: nonOECD?
Your answer should be very brief. 3.87. What is the ratio of the Payments (BoP, current US$) in 2008 in European Union to that in High income: nonOECD?
Make the answer very short. 3.61. What is the ratio of the Payments (BoP, current US$) of 2005 in High income to that in High income: nonOECD?
Your answer should be very brief. 7.66. What is the ratio of the Payments (BoP, current US$) in 2006 in High income to that in High income: nonOECD?
Give a very brief answer. 7.46. What is the ratio of the Payments (BoP, current US$) of 2007 in High income to that in High income: nonOECD?
Your answer should be compact. 7.31. What is the ratio of the Payments (BoP, current US$) of 2008 in High income to that in High income: nonOECD?
Give a very brief answer. 6.86. What is the difference between the highest and the second highest Payments (BoP, current US$) of 2005?
Offer a very short reply. 5.27e+12. What is the difference between the highest and the second highest Payments (BoP, current US$) of 2006?
Offer a very short reply. 6.06e+12. What is the difference between the highest and the second highest Payments (BoP, current US$) in 2007?
Your response must be concise. 6.70e+12. What is the difference between the highest and the second highest Payments (BoP, current US$) in 2008?
Provide a short and direct response. 7.28e+12. What is the difference between the highest and the lowest Payments (BoP, current US$) in 2005?
Provide a short and direct response. 1.21e+13. What is the difference between the highest and the lowest Payments (BoP, current US$) in 2006?
Provide a short and direct response. 1.41e+13. What is the difference between the highest and the lowest Payments (BoP, current US$) of 2007?
Your answer should be compact. 1.65e+13. What is the difference between the highest and the lowest Payments (BoP, current US$) of 2008?
Ensure brevity in your answer.  1.81e+13. 